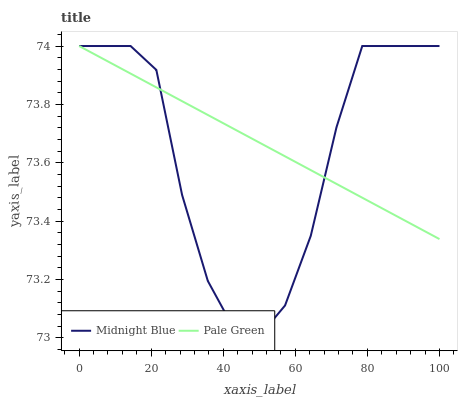Does Midnight Blue have the minimum area under the curve?
Answer yes or no. Yes. Does Pale Green have the maximum area under the curve?
Answer yes or no. Yes. Does Midnight Blue have the maximum area under the curve?
Answer yes or no. No. Is Pale Green the smoothest?
Answer yes or no. Yes. Is Midnight Blue the roughest?
Answer yes or no. Yes. Is Midnight Blue the smoothest?
Answer yes or no. No. Does Midnight Blue have the lowest value?
Answer yes or no. Yes. Does Midnight Blue have the highest value?
Answer yes or no. Yes. Does Midnight Blue intersect Pale Green?
Answer yes or no. Yes. Is Midnight Blue less than Pale Green?
Answer yes or no. No. Is Midnight Blue greater than Pale Green?
Answer yes or no. No. 